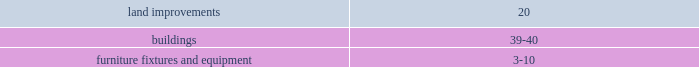The contractual maturities of held-to-maturity securities as of january 30 , 2009 were in excess of three years and were $ 31.4 million at cost and $ 28.9 million at fair value , respectively .
For the successor year ended january 30 , 2009 and period ended february 1 , 2008 , and the predecessor period ended july 6 , 2007 and year ended february 2 , 2007 , gross realized gains and losses on the sales of available-for-sale securities were not material .
The cost of securities sold is based upon the specific identification method .
Merchandise inventories inventories are stated at the lower of cost or market with cost determined using the retail last-in , first-out ( 201clifo 201d ) method .
Under the company 2019s retail inventory method ( 201crim 201d ) , the calculation of gross profit and the resulting valuation of inventories at cost are computed by applying a calculated cost-to-retail inventory ratio to the retail value of sales at a department level .
Costs directly associated with warehousing and distribution are capitalized into inventory .
The excess of current cost over lifo cost was approximately $ 50.0 million at january 30 , 2009 and $ 6.1 million at february 1 , 2008 .
Current cost is determined using the retail first-in , first-out method .
The company 2019s lifo reserves were adjusted to zero at july 6 , 2007 as a result of the merger .
The successor recorded lifo provisions of $ 43.9 million and $ 6.1 million during 2008 and 2007 , respectively .
The predecessor recorded a lifo credit of $ 1.5 million in 2006 .
In 2008 , the increased commodity cost pressures mainly related to food and pet products which have been driven by fruit and vegetable prices and rising freight costs .
Increases in petroleum , resin , metals , pulp and other raw material commodity driven costs also resulted in multiple product cost increases .
The company intends to address these commodity cost increases through negotiations with its vendors and by increasing retail prices as necessary .
On a quarterly basis , the company estimates the annual impact of commodity cost fluctuations based upon the best available information at that point in time .
Store pre-opening costs pre-opening costs related to new store openings and the construction periods are expensed as incurred .
Property and equipment property and equipment are recorded at cost .
The company provides for depreciation and amortization on a straight-line basis over the following estimated useful lives: .
Improvements of leased properties are amortized over the shorter of the life of the applicable lease term or the estimated useful life of the asset. .
What was the percentage change in the excess of current cost over lifo cost from 2008 to 2009 .? 
Rationale: the percentage change is the change from the recent to the most recent divide by the recent
Computations: (50.0 - 6.1)
Answer: 43.9. 